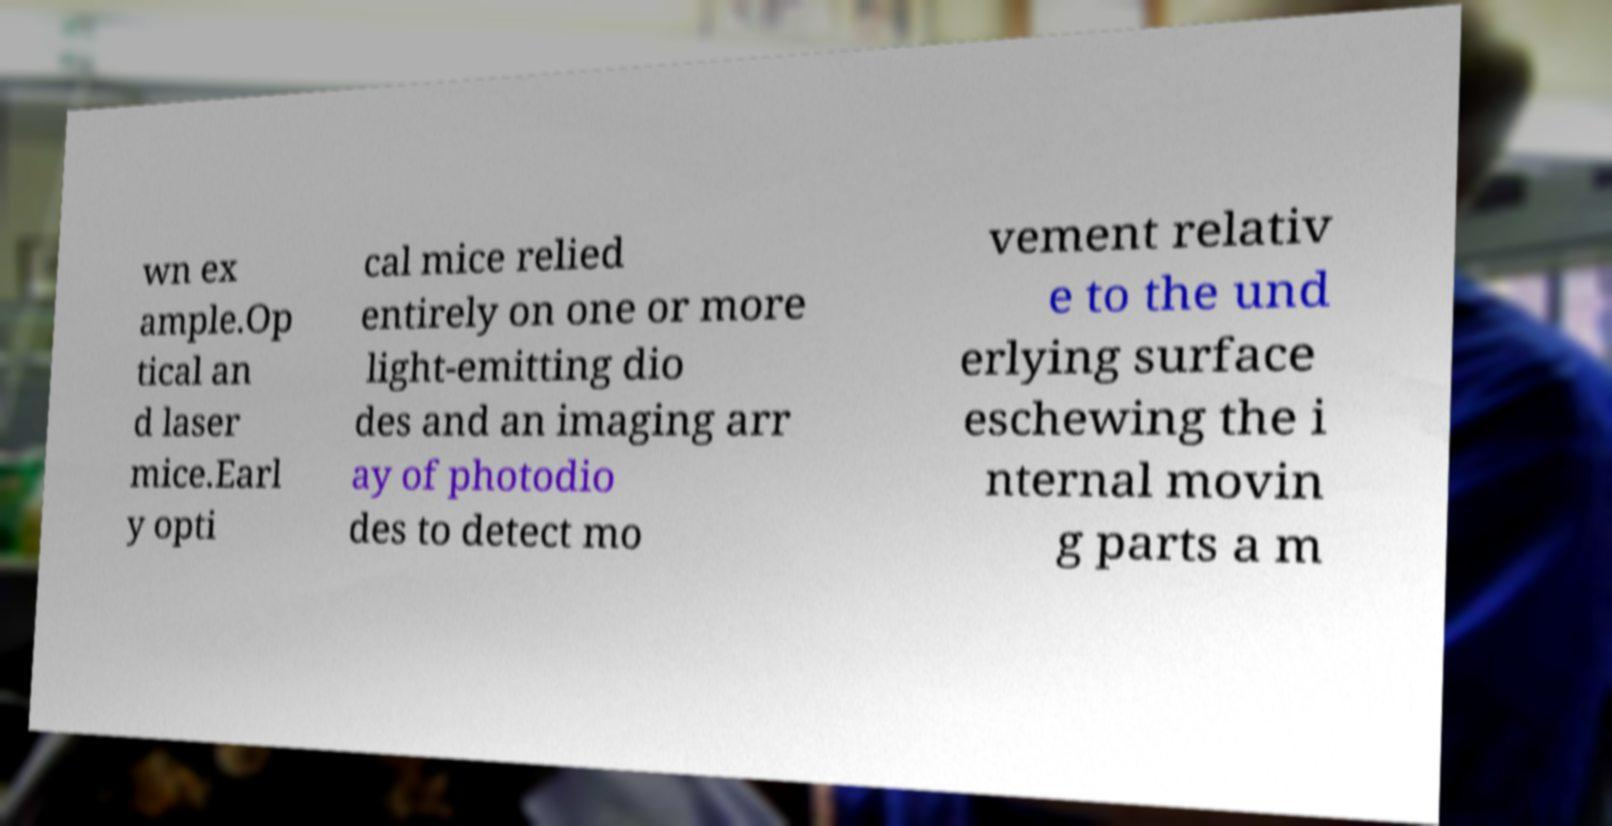There's text embedded in this image that I need extracted. Can you transcribe it verbatim? wn ex ample.Op tical an d laser mice.Earl y opti cal mice relied entirely on one or more light-emitting dio des and an imaging arr ay of photodio des to detect mo vement relativ e to the und erlying surface eschewing the i nternal movin g parts a m 